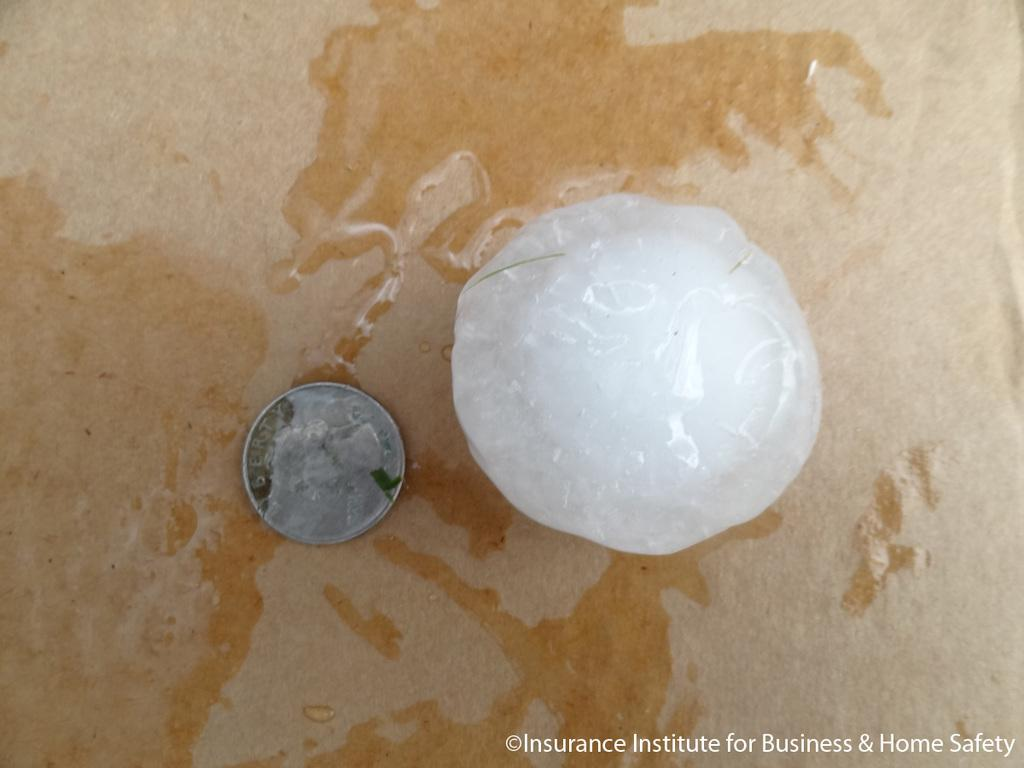<image>
Create a compact narrative representing the image presented. Liberty silver coin beside a clear ball that is wet 